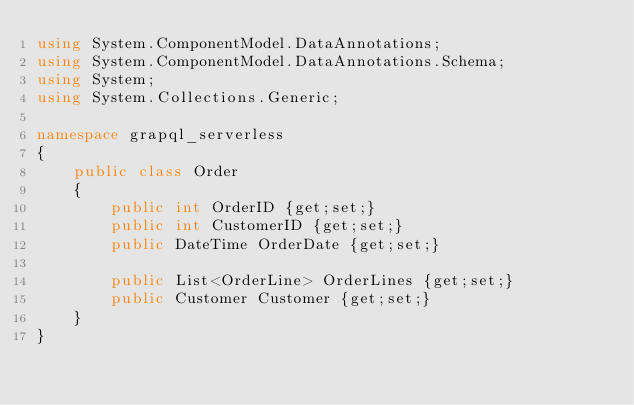<code> <loc_0><loc_0><loc_500><loc_500><_C#_>using System.ComponentModel.DataAnnotations;
using System.ComponentModel.DataAnnotations.Schema;
using System;
using System.Collections.Generic;

namespace grapql_serverless
{
    public class Order
    {
        public int OrderID {get;set;}
        public int CustomerID {get;set;}
        public DateTime OrderDate {get;set;}

        public List<OrderLine> OrderLines {get;set;}
        public Customer Customer {get;set;}
    }
}</code> 